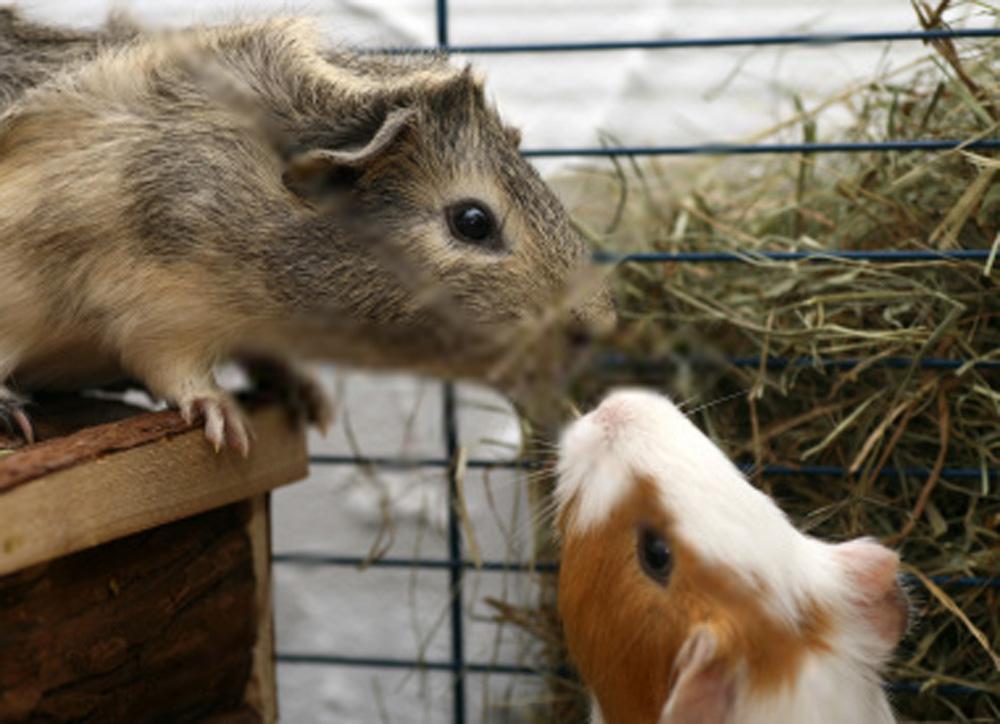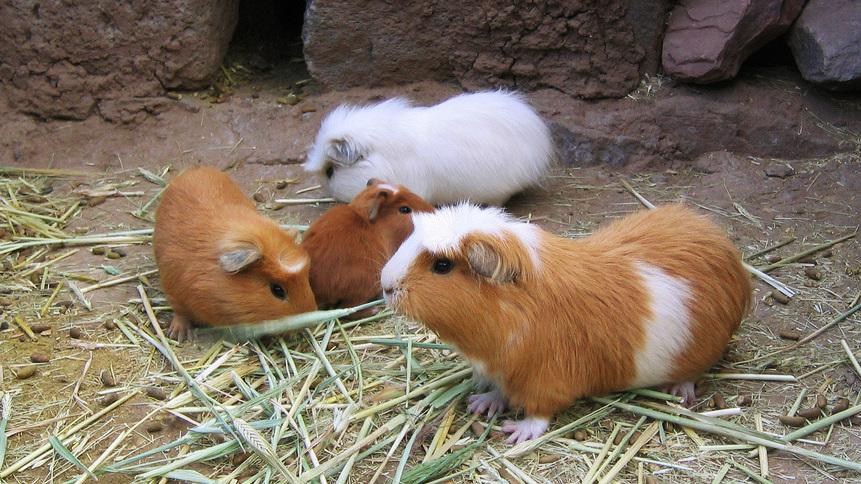The first image is the image on the left, the second image is the image on the right. Assess this claim about the two images: "One image shows guinea pigs in the corner of an enclosure with plant matter on its floor, and the other image shows a guinea pig by a structure made of side-by-side wood rods.". Correct or not? Answer yes or no. No. The first image is the image on the left, the second image is the image on the right. Evaluate the accuracy of this statement regarding the images: "There are no more than two animals in a wire cage in one of the images.". Is it true? Answer yes or no. Yes. 